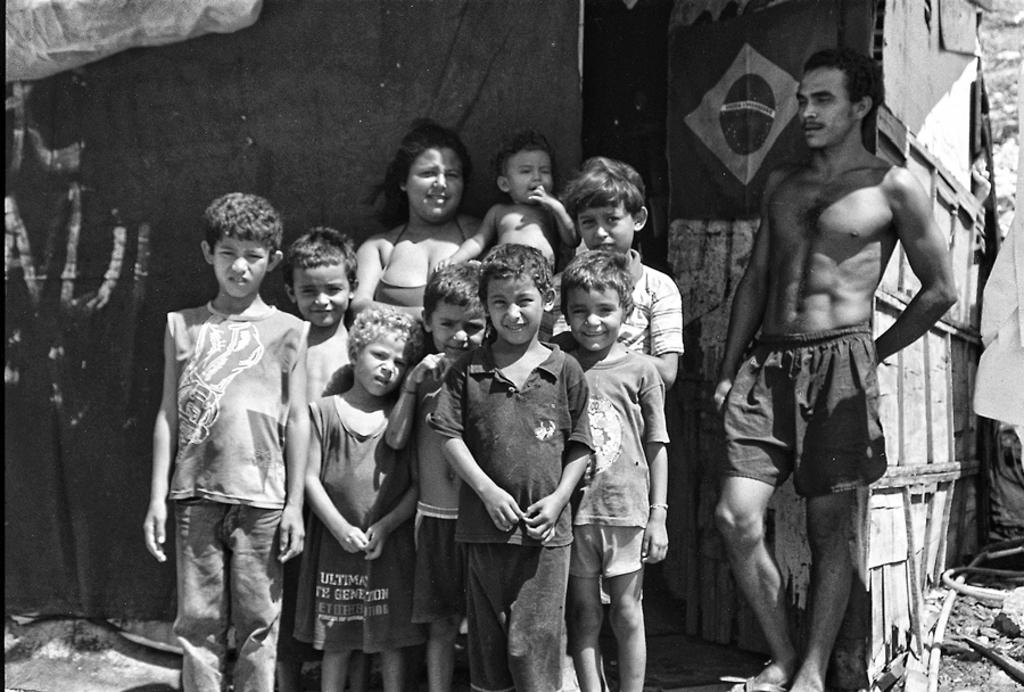What can be seen in the image involving children? There are kids standing in the image. What is the woman in the image doing? The woman is carrying a baby in the image. Can you describe the man in the image? There is a man in the image. What else is present in the image besides the people? There are other objects in the image. How many icicles are hanging from the man's hat in the image? There are no icicles present in the image, as it does not mention any ice or cold weather conditions. 